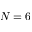<formula> <loc_0><loc_0><loc_500><loc_500>N = 6</formula> 